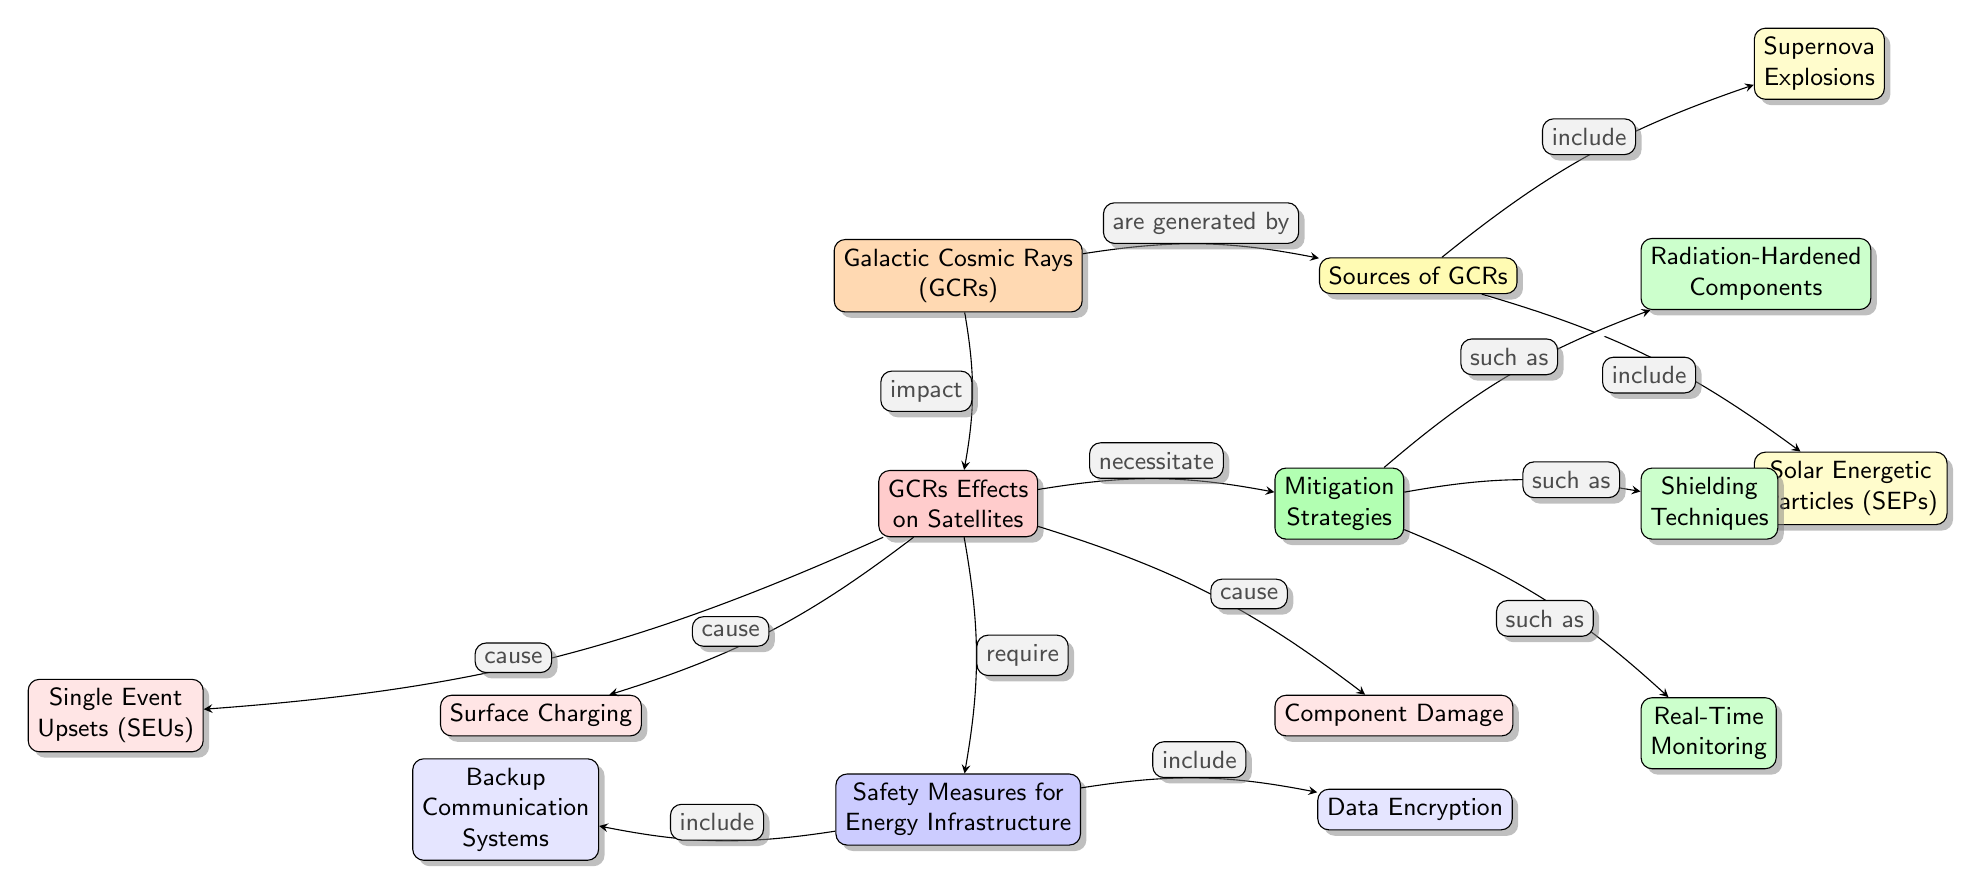What are the sources of Galactic Cosmic Rays? The diagram identifies two sources of Galactic Cosmic Rays, which are located in the node connected to "Sources of GCRs". They are "Supernova Explosions" and "Solar Energetic Particles (SEPs)".
Answer: Supernova Explosions, Solar Energetic Particles (SEPs) What is one effect of GCRs on satellites? Under the node "GCRs Effects on Satellites", three effects are mentioned: "Surface Charging", "Single Event Upsets (SEUs)", and "Component Damage". They indicate the adverse impacts on satellite operations.
Answer: Surface Charging What is a type of mitigation strategy mentioned in the diagram? The diagram lists three mitigation strategies under "Mitigation Strategies". They are "Radiation-Hardened Components", "Shielding Techniques", and "Real-Time Monitoring". Any of these can be considered a valid answer.
Answer: Radiation-Hardened Components How do GCRs impact satellite communications? The effect of GCRs on satellites is illustrated in the "GCRs Effects on Satellites" node, where it indicates that the impacts include "Surface Charging", "Single Event Upsets (SEUs)", and "Component Damage”. This relationship highlights that GCRs can negatively influence satellite communication reliability.
Answer: They impact communication reliability What are safety measures for energy infrastructure against GCRs? The node "Safety Measures for Energy Infrastructure" outlines two safety measures: "Backup Communication Systems" and "Data Encryption". These measures are important for protecting energy communication systems from the potentially disruptive effects of GCRs.
Answer: Backup Communication Systems, Data Encryption What necessitates mitigation strategies for satellites? Mitigation strategies are necessitated by the effects that GCRs have on satellites, listed in the diagram under "GCRs Effects on Satellites". The reason for their need can be traced back to the impacts caused by GCRs, such as surface charging and component damage.
Answer: GCRs Effects on Satellites What type of components can be used as a mitigation strategy? One type of component proposed is "Radiation-Hardened Components". They are designed specifically to withstand the adverse effects of radiation, including those caused by GCRs, thereby ensuring satellite functionality and reliability.
Answer: Radiation-Hardened Components Which component effect is most related to GCRs? Within "GCRs Effects on Satellites", "Component Damage" references the physical damage that GCRs can inflict on satellite components, making this effect closely associated with GCRs.
Answer: Component Damage 